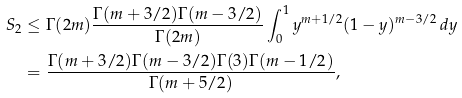Convert formula to latex. <formula><loc_0><loc_0><loc_500><loc_500>S _ { 2 } & \leq \Gamma ( 2 m ) \frac { \Gamma ( m + 3 / 2 ) \Gamma ( m - 3 / 2 ) } { \Gamma ( 2 m ) } \int _ { 0 } ^ { 1 } y ^ { m + 1 / 2 } ( 1 - y ) ^ { m - 3 / 2 } \, d y \\ & = \frac { \Gamma ( m + 3 / 2 ) \Gamma ( m - 3 / 2 ) \Gamma ( 3 ) \Gamma ( m - 1 / 2 ) } { \Gamma ( m + 5 / 2 ) } ,</formula> 